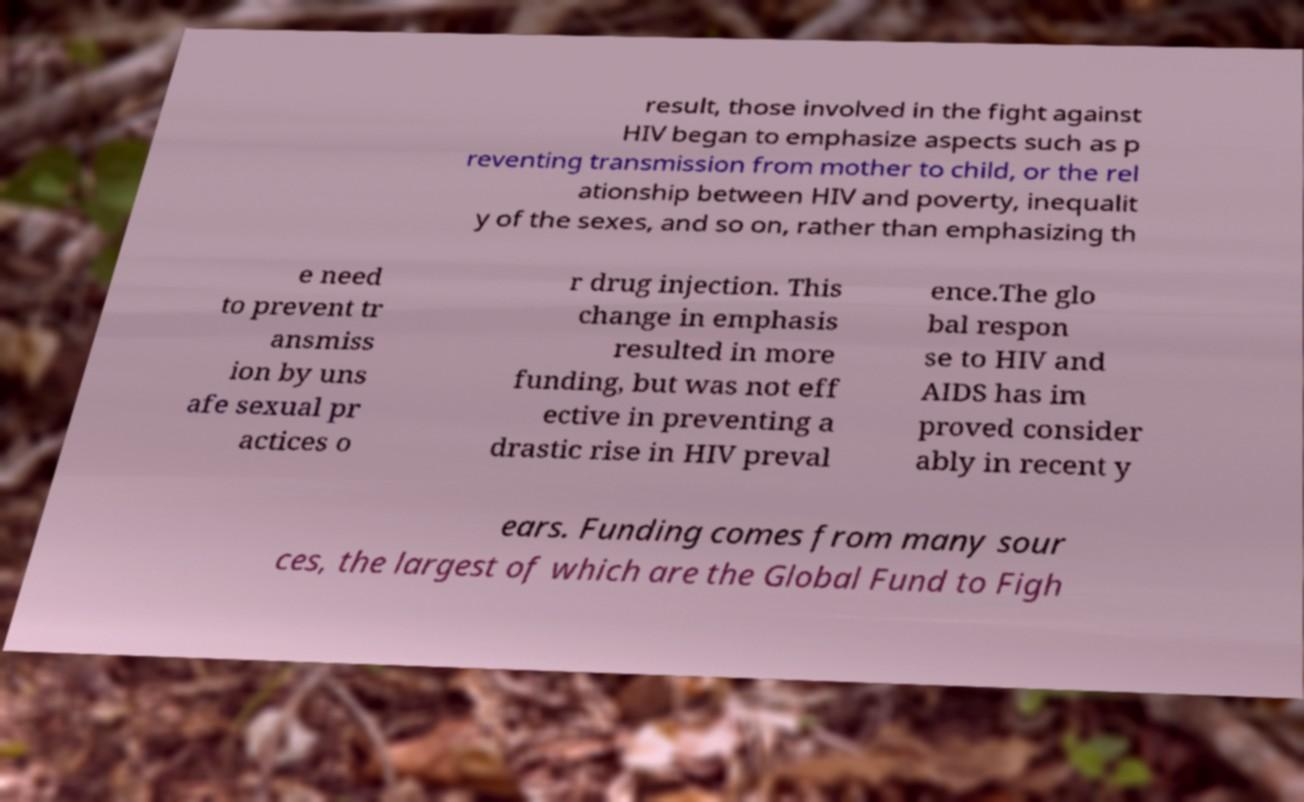There's text embedded in this image that I need extracted. Can you transcribe it verbatim? result, those involved in the fight against HIV began to emphasize aspects such as p reventing transmission from mother to child, or the rel ationship between HIV and poverty, inequalit y of the sexes, and so on, rather than emphasizing th e need to prevent tr ansmiss ion by uns afe sexual pr actices o r drug injection. This change in emphasis resulted in more funding, but was not eff ective in preventing a drastic rise in HIV preval ence.The glo bal respon se to HIV and AIDS has im proved consider ably in recent y ears. Funding comes from many sour ces, the largest of which are the Global Fund to Figh 